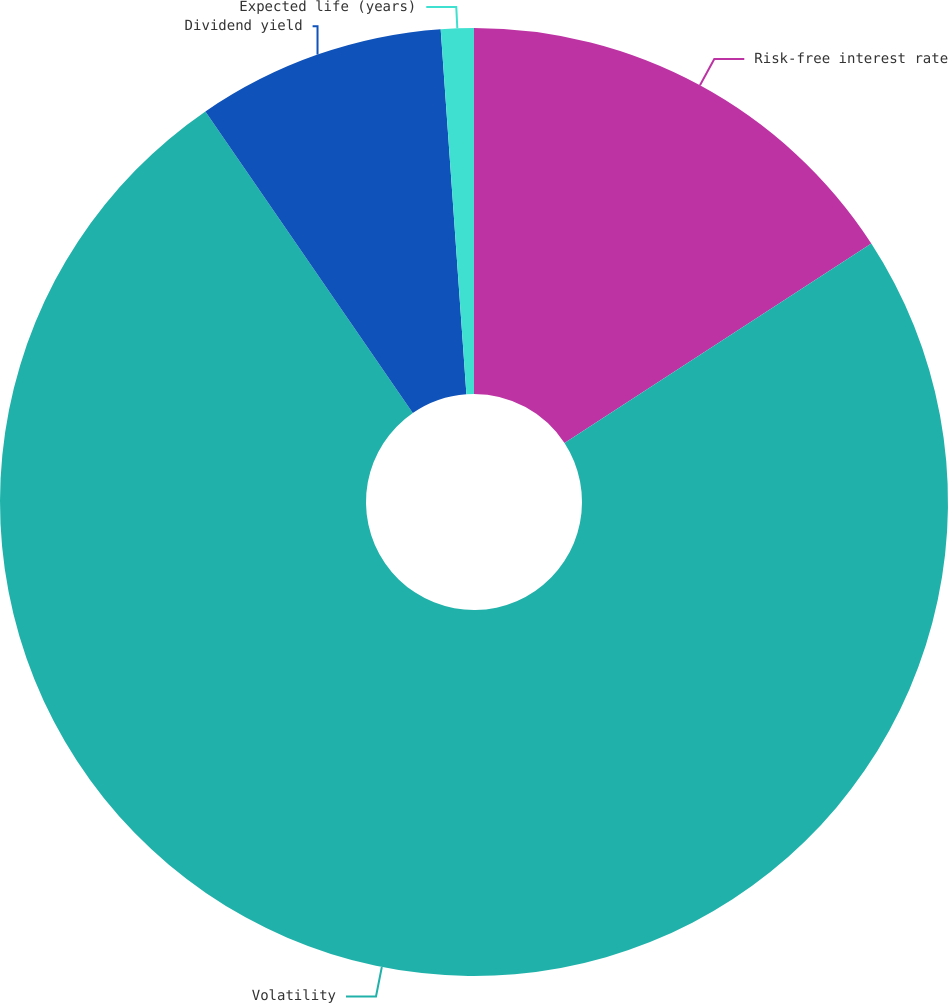Convert chart. <chart><loc_0><loc_0><loc_500><loc_500><pie_chart><fcel>Risk-free interest rate<fcel>Volatility<fcel>Dividend yield<fcel>Expected life (years)<nl><fcel>15.82%<fcel>74.6%<fcel>8.47%<fcel>1.12%<nl></chart> 